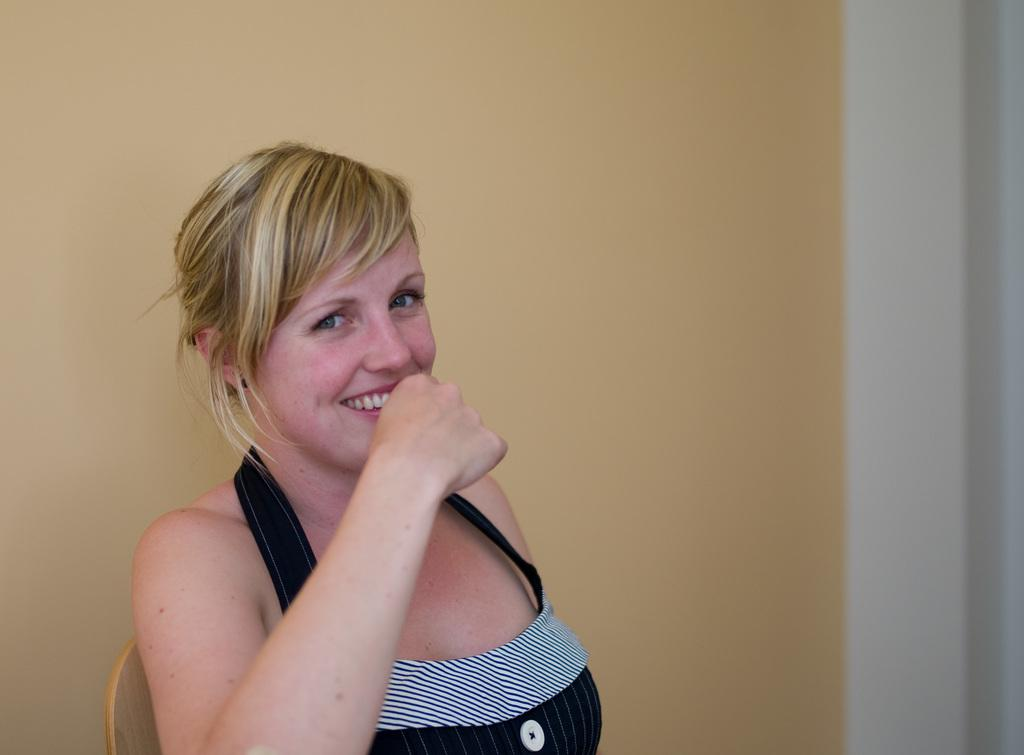Who is the main subject in the image? There is a woman in the image. What is the woman wearing? The woman is wearing a black and white dress. What is the woman doing in the image? The woman is sitting on a chair. What can be seen in the background of the image? There is a cream and white colored wall in the background. Can you see any goldfish swimming in the background of the image? There are no goldfish present in the image. What type of polish is the woman using on her nails in the image? The image does not show the woman using any polish on her nails. 